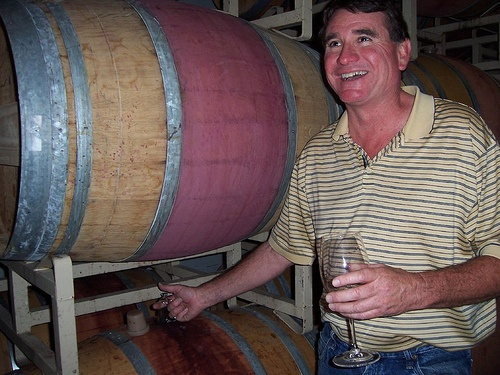Describe the objects in this image and their specific colors. I can see people in black, gray, darkgray, and brown tones and wine glass in black, gray, and darkgray tones in this image. 